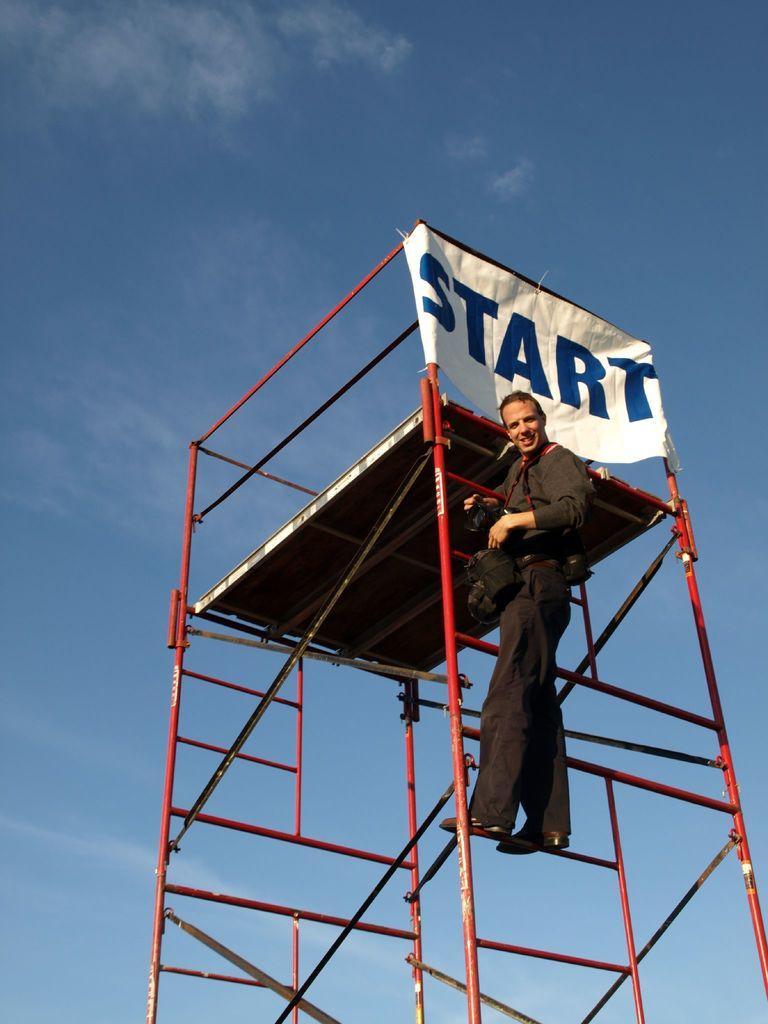In one or two sentences, can you explain what this image depicts? In this image we can see a person holding a camera and standing on the object, which looks like a tower, also we can see banner with text on it, in the background we can see the sky with clouds. 